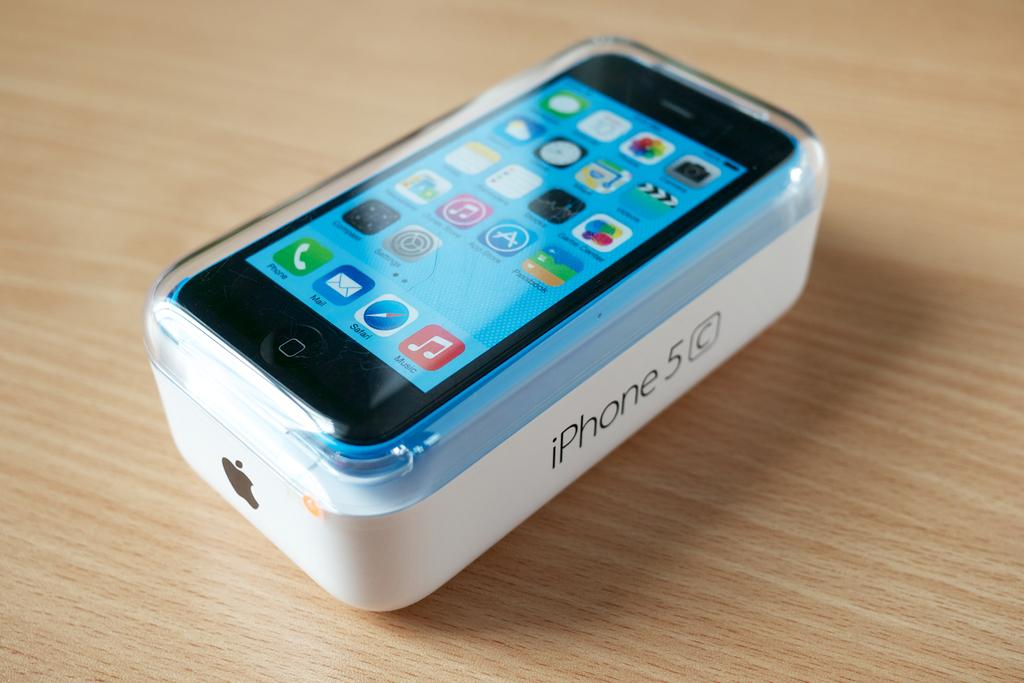<image>
Render a clear and concise summary of the photo. a phone with the word iPhone 5 on it 